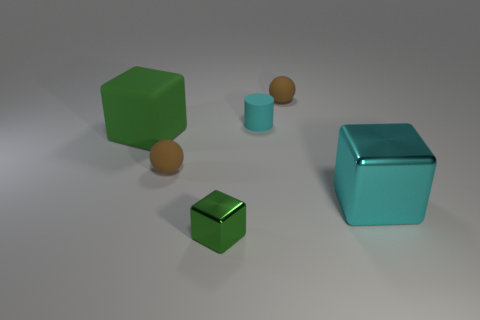Add 3 big things. How many objects exist? 9 Subtract all cylinders. How many objects are left? 5 Add 5 tiny cylinders. How many tiny cylinders exist? 6 Subtract 0 purple spheres. How many objects are left? 6 Subtract all large red matte spheres. Subtract all brown matte things. How many objects are left? 4 Add 5 large cyan metallic cubes. How many large cyan metallic cubes are left? 6 